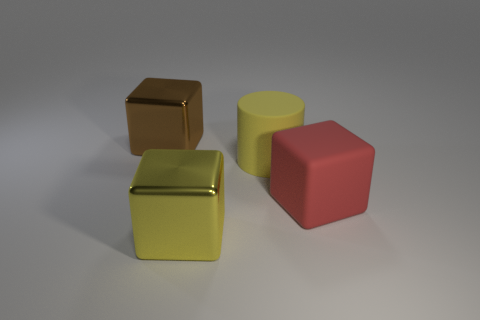Add 4 large red rubber things. How many objects exist? 8 Subtract all cylinders. How many objects are left? 3 Add 3 big rubber blocks. How many big rubber blocks exist? 4 Subtract 0 blue spheres. How many objects are left? 4 Subtract all red objects. Subtract all big yellow shiny cubes. How many objects are left? 2 Add 4 matte blocks. How many matte blocks are left? 5 